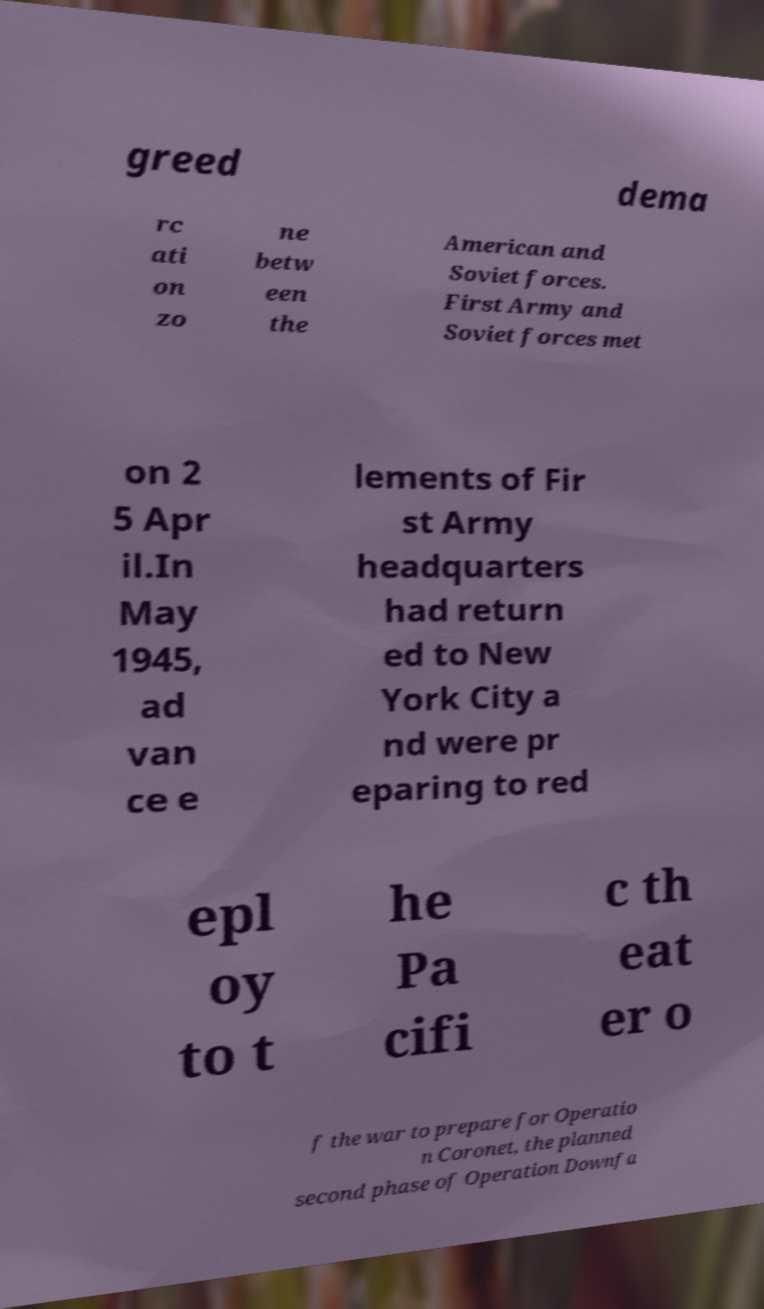There's text embedded in this image that I need extracted. Can you transcribe it verbatim? greed dema rc ati on zo ne betw een the American and Soviet forces. First Army and Soviet forces met on 2 5 Apr il.In May 1945, ad van ce e lements of Fir st Army headquarters had return ed to New York City a nd were pr eparing to red epl oy to t he Pa cifi c th eat er o f the war to prepare for Operatio n Coronet, the planned second phase of Operation Downfa 